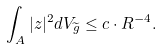<formula> <loc_0><loc_0><loc_500><loc_500>\int _ { A } | z | ^ { 2 } d V _ { \widetilde { g } } \leq c \cdot R ^ { - 4 } .</formula> 